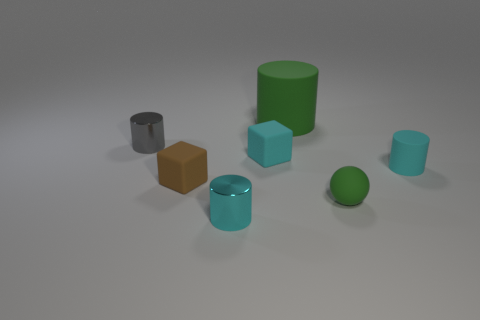Subtract all cyan rubber cylinders. How many cylinders are left? 3 Add 2 tiny gray metallic objects. How many objects exist? 9 Subtract 2 cylinders. How many cylinders are left? 2 Subtract all gray cylinders. How many cylinders are left? 3 Subtract all gray spheres. How many blue cylinders are left? 0 Subtract all tiny gray shiny things. Subtract all big red rubber cylinders. How many objects are left? 6 Add 3 large green rubber things. How many large green rubber things are left? 4 Add 3 tiny objects. How many tiny objects exist? 9 Subtract 1 green cylinders. How many objects are left? 6 Subtract all blocks. How many objects are left? 5 